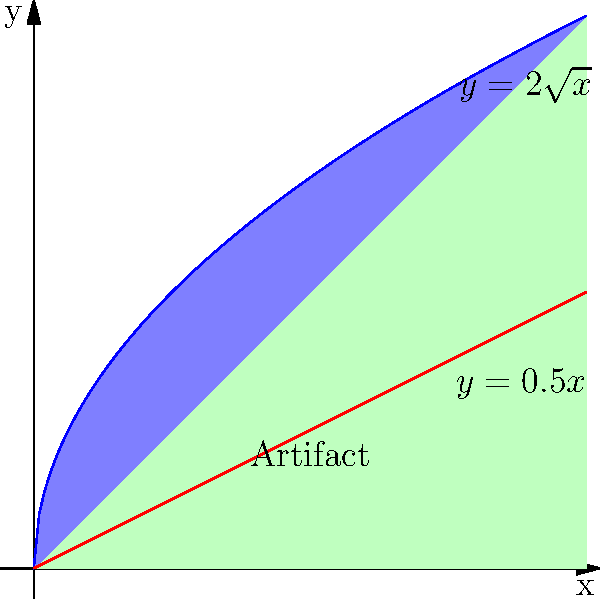An ancient Roman vase has been discovered, and its cross-section can be modeled by rotating the region bounded by the curves $y=2\sqrt{x}$, $y=0.5x$, and the y-axis around the x-axis. Calculate the volume of this vase using integration techniques. Round your answer to the nearest cubic centimeter, assuming the x and y axes are measured in centimeters. To find the volume of the vase, we need to use the washer method for volumes of revolution:

1) The volume is given by the formula:
   $$V = \pi \int_a^b [R(x)^2 - r(x)^2] dx$$
   where $R(x)$ is the outer function and $r(x)$ is the inner function.

2) In this case, $R(x) = 2\sqrt{x}$ and $r(x) = 0.5x$

3) We need to find the intersection point of these functions to determine the upper limit of integration:
   $2\sqrt{x} = 0.5x$
   $4x = x^2$
   $x^2 - 4x = 0$
   $x(x-4) = 0$
   $x = 0$ or $x = 4$
   The upper limit is $x = 4$, and the lower limit is $x = 0$.

4) Now we can set up our integral:
   $$V = \pi \int_0^4 [(2\sqrt{x})^2 - (0.5x)^2] dx$$

5) Simplify the integrand:
   $$V = \pi \int_0^4 [4x - 0.25x^2] dx$$

6) Integrate:
   $$V = \pi [2x^2 - \frac{1}{12}x^3]_0^4$$

7) Evaluate the integral:
   $$V = \pi [(32 - \frac{64}{3}) - (0 - 0)]$$
   $$V = \pi (32 - \frac{64}{3})$$
   $$V = \pi (\frac{96}{3} - \frac{64}{3})$$
   $$V = \pi (\frac{32}{3})$$
   $$V = \frac{32\pi}{3} \approx 33.51 \text{ cm}^3$$

8) Rounding to the nearest cubic centimeter:
   $$V \approx 34 \text{ cm}^3$$
Answer: 34 cm³ 